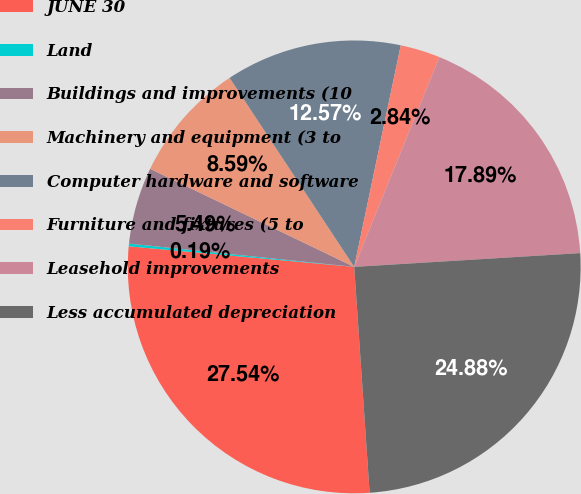Convert chart to OTSL. <chart><loc_0><loc_0><loc_500><loc_500><pie_chart><fcel>JUNE 30<fcel>Land<fcel>Buildings and improvements (10<fcel>Machinery and equipment (3 to<fcel>Computer hardware and software<fcel>Furniture and fixtures (5 to<fcel>Leasehold improvements<fcel>Less accumulated depreciation<nl><fcel>27.53%<fcel>0.19%<fcel>5.49%<fcel>8.59%<fcel>12.57%<fcel>2.84%<fcel>17.89%<fcel>24.88%<nl></chart> 